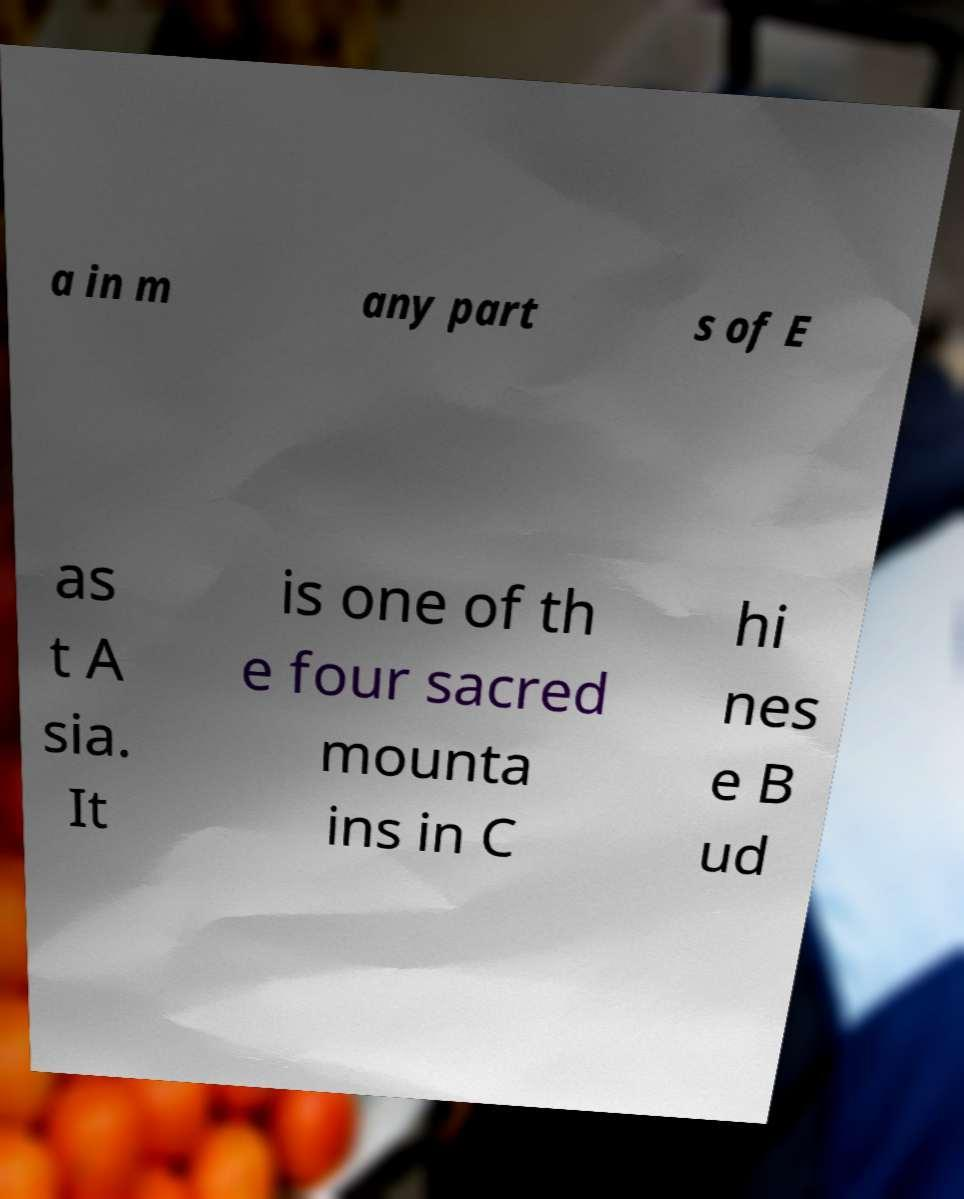Can you accurately transcribe the text from the provided image for me? a in m any part s of E as t A sia. It is one of th e four sacred mounta ins in C hi nes e B ud 